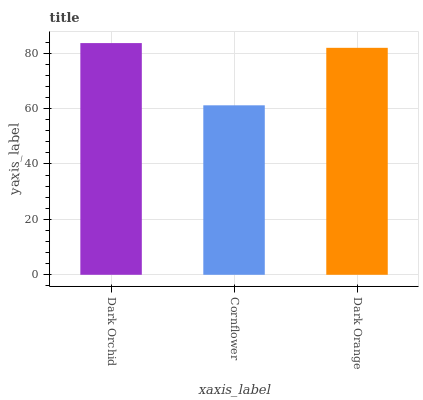Is Dark Orange the minimum?
Answer yes or no. No. Is Dark Orange the maximum?
Answer yes or no. No. Is Dark Orange greater than Cornflower?
Answer yes or no. Yes. Is Cornflower less than Dark Orange?
Answer yes or no. Yes. Is Cornflower greater than Dark Orange?
Answer yes or no. No. Is Dark Orange less than Cornflower?
Answer yes or no. No. Is Dark Orange the high median?
Answer yes or no. Yes. Is Dark Orange the low median?
Answer yes or no. Yes. Is Dark Orchid the high median?
Answer yes or no. No. Is Cornflower the low median?
Answer yes or no. No. 